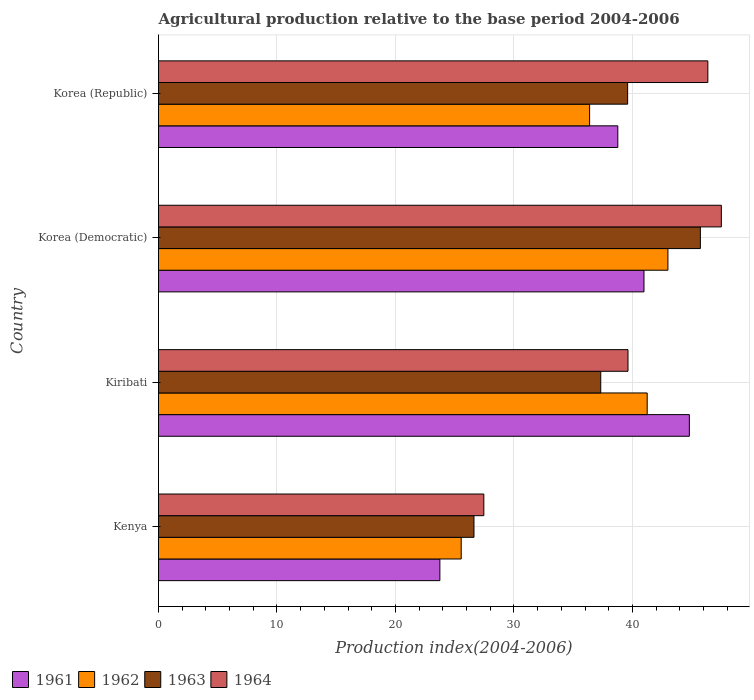How many groups of bars are there?
Your response must be concise. 4. Are the number of bars per tick equal to the number of legend labels?
Make the answer very short. Yes. How many bars are there on the 3rd tick from the top?
Ensure brevity in your answer.  4. What is the label of the 1st group of bars from the top?
Offer a very short reply. Korea (Republic). What is the agricultural production index in 1964 in Korea (Democratic)?
Offer a terse response. 47.51. Across all countries, what is the maximum agricultural production index in 1962?
Your answer should be very brief. 43. Across all countries, what is the minimum agricultural production index in 1962?
Your answer should be very brief. 25.55. In which country was the agricultural production index in 1964 maximum?
Offer a very short reply. Korea (Democratic). In which country was the agricultural production index in 1962 minimum?
Ensure brevity in your answer.  Kenya. What is the total agricultural production index in 1963 in the graph?
Give a very brief answer. 149.3. What is the difference between the agricultural production index in 1964 in Kiribati and that in Korea (Republic)?
Ensure brevity in your answer.  -6.74. What is the difference between the agricultural production index in 1963 in Korea (Republic) and the agricultural production index in 1961 in Korea (Democratic)?
Your response must be concise. -1.38. What is the average agricultural production index in 1964 per country?
Your answer should be compact. 40.24. What is the difference between the agricultural production index in 1961 and agricultural production index in 1964 in Kiribati?
Give a very brief answer. 5.18. What is the ratio of the agricultural production index in 1961 in Kenya to that in Korea (Democratic)?
Make the answer very short. 0.58. Is the agricultural production index in 1962 in Kenya less than that in Korea (Democratic)?
Provide a short and direct response. Yes. Is the difference between the agricultural production index in 1961 in Kiribati and Korea (Republic) greater than the difference between the agricultural production index in 1964 in Kiribati and Korea (Republic)?
Make the answer very short. Yes. What is the difference between the highest and the second highest agricultural production index in 1961?
Offer a very short reply. 3.83. What is the difference between the highest and the lowest agricultural production index in 1961?
Ensure brevity in your answer.  21.06. Is the sum of the agricultural production index in 1964 in Kenya and Kiribati greater than the maximum agricultural production index in 1963 across all countries?
Ensure brevity in your answer.  Yes. Is it the case that in every country, the sum of the agricultural production index in 1964 and agricultural production index in 1963 is greater than the sum of agricultural production index in 1961 and agricultural production index in 1962?
Offer a very short reply. No. What does the 1st bar from the top in Kiribati represents?
Your response must be concise. 1964. How many countries are there in the graph?
Ensure brevity in your answer.  4. What is the difference between two consecutive major ticks on the X-axis?
Your answer should be compact. 10. Are the values on the major ticks of X-axis written in scientific E-notation?
Your answer should be very brief. No. Does the graph contain any zero values?
Offer a very short reply. No. Does the graph contain grids?
Offer a very short reply. Yes. Where does the legend appear in the graph?
Offer a terse response. Bottom left. What is the title of the graph?
Provide a short and direct response. Agricultural production relative to the base period 2004-2006. What is the label or title of the X-axis?
Your answer should be compact. Production index(2004-2006). What is the Production index(2004-2006) in 1961 in Kenya?
Your answer should be compact. 23.75. What is the Production index(2004-2006) of 1962 in Kenya?
Offer a very short reply. 25.55. What is the Production index(2004-2006) in 1963 in Kenya?
Your answer should be very brief. 26.63. What is the Production index(2004-2006) of 1964 in Kenya?
Offer a terse response. 27.46. What is the Production index(2004-2006) in 1961 in Kiribati?
Make the answer very short. 44.81. What is the Production index(2004-2006) of 1962 in Kiribati?
Keep it short and to the point. 41.25. What is the Production index(2004-2006) of 1963 in Kiribati?
Provide a short and direct response. 37.33. What is the Production index(2004-2006) in 1964 in Kiribati?
Ensure brevity in your answer.  39.63. What is the Production index(2004-2006) of 1961 in Korea (Democratic)?
Make the answer very short. 40.98. What is the Production index(2004-2006) in 1963 in Korea (Democratic)?
Offer a very short reply. 45.74. What is the Production index(2004-2006) in 1964 in Korea (Democratic)?
Offer a very short reply. 47.51. What is the Production index(2004-2006) in 1961 in Korea (Republic)?
Offer a very short reply. 38.77. What is the Production index(2004-2006) in 1962 in Korea (Republic)?
Give a very brief answer. 36.39. What is the Production index(2004-2006) of 1963 in Korea (Republic)?
Provide a short and direct response. 39.6. What is the Production index(2004-2006) of 1964 in Korea (Republic)?
Offer a very short reply. 46.37. Across all countries, what is the maximum Production index(2004-2006) in 1961?
Ensure brevity in your answer.  44.81. Across all countries, what is the maximum Production index(2004-2006) of 1962?
Give a very brief answer. 43. Across all countries, what is the maximum Production index(2004-2006) of 1963?
Provide a short and direct response. 45.74. Across all countries, what is the maximum Production index(2004-2006) in 1964?
Your answer should be very brief. 47.51. Across all countries, what is the minimum Production index(2004-2006) in 1961?
Give a very brief answer. 23.75. Across all countries, what is the minimum Production index(2004-2006) in 1962?
Provide a succinct answer. 25.55. Across all countries, what is the minimum Production index(2004-2006) of 1963?
Your answer should be very brief. 26.63. Across all countries, what is the minimum Production index(2004-2006) of 1964?
Offer a very short reply. 27.46. What is the total Production index(2004-2006) of 1961 in the graph?
Offer a very short reply. 148.31. What is the total Production index(2004-2006) in 1962 in the graph?
Offer a terse response. 146.19. What is the total Production index(2004-2006) of 1963 in the graph?
Keep it short and to the point. 149.3. What is the total Production index(2004-2006) of 1964 in the graph?
Give a very brief answer. 160.97. What is the difference between the Production index(2004-2006) in 1961 in Kenya and that in Kiribati?
Make the answer very short. -21.06. What is the difference between the Production index(2004-2006) in 1962 in Kenya and that in Kiribati?
Offer a very short reply. -15.7. What is the difference between the Production index(2004-2006) of 1963 in Kenya and that in Kiribati?
Provide a short and direct response. -10.7. What is the difference between the Production index(2004-2006) in 1964 in Kenya and that in Kiribati?
Offer a very short reply. -12.17. What is the difference between the Production index(2004-2006) of 1961 in Kenya and that in Korea (Democratic)?
Offer a terse response. -17.23. What is the difference between the Production index(2004-2006) of 1962 in Kenya and that in Korea (Democratic)?
Make the answer very short. -17.45. What is the difference between the Production index(2004-2006) in 1963 in Kenya and that in Korea (Democratic)?
Give a very brief answer. -19.11. What is the difference between the Production index(2004-2006) in 1964 in Kenya and that in Korea (Democratic)?
Your answer should be compact. -20.05. What is the difference between the Production index(2004-2006) of 1961 in Kenya and that in Korea (Republic)?
Provide a short and direct response. -15.02. What is the difference between the Production index(2004-2006) of 1962 in Kenya and that in Korea (Republic)?
Your answer should be very brief. -10.84. What is the difference between the Production index(2004-2006) in 1963 in Kenya and that in Korea (Republic)?
Offer a very short reply. -12.97. What is the difference between the Production index(2004-2006) in 1964 in Kenya and that in Korea (Republic)?
Your answer should be very brief. -18.91. What is the difference between the Production index(2004-2006) of 1961 in Kiribati and that in Korea (Democratic)?
Your answer should be compact. 3.83. What is the difference between the Production index(2004-2006) in 1962 in Kiribati and that in Korea (Democratic)?
Offer a terse response. -1.75. What is the difference between the Production index(2004-2006) of 1963 in Kiribati and that in Korea (Democratic)?
Make the answer very short. -8.41. What is the difference between the Production index(2004-2006) of 1964 in Kiribati and that in Korea (Democratic)?
Your response must be concise. -7.88. What is the difference between the Production index(2004-2006) of 1961 in Kiribati and that in Korea (Republic)?
Keep it short and to the point. 6.04. What is the difference between the Production index(2004-2006) of 1962 in Kiribati and that in Korea (Republic)?
Keep it short and to the point. 4.86. What is the difference between the Production index(2004-2006) in 1963 in Kiribati and that in Korea (Republic)?
Make the answer very short. -2.27. What is the difference between the Production index(2004-2006) in 1964 in Kiribati and that in Korea (Republic)?
Ensure brevity in your answer.  -6.74. What is the difference between the Production index(2004-2006) of 1961 in Korea (Democratic) and that in Korea (Republic)?
Your answer should be very brief. 2.21. What is the difference between the Production index(2004-2006) in 1962 in Korea (Democratic) and that in Korea (Republic)?
Provide a succinct answer. 6.61. What is the difference between the Production index(2004-2006) in 1963 in Korea (Democratic) and that in Korea (Republic)?
Provide a short and direct response. 6.14. What is the difference between the Production index(2004-2006) in 1964 in Korea (Democratic) and that in Korea (Republic)?
Your answer should be compact. 1.14. What is the difference between the Production index(2004-2006) of 1961 in Kenya and the Production index(2004-2006) of 1962 in Kiribati?
Give a very brief answer. -17.5. What is the difference between the Production index(2004-2006) in 1961 in Kenya and the Production index(2004-2006) in 1963 in Kiribati?
Make the answer very short. -13.58. What is the difference between the Production index(2004-2006) in 1961 in Kenya and the Production index(2004-2006) in 1964 in Kiribati?
Offer a very short reply. -15.88. What is the difference between the Production index(2004-2006) of 1962 in Kenya and the Production index(2004-2006) of 1963 in Kiribati?
Make the answer very short. -11.78. What is the difference between the Production index(2004-2006) of 1962 in Kenya and the Production index(2004-2006) of 1964 in Kiribati?
Your answer should be very brief. -14.08. What is the difference between the Production index(2004-2006) in 1961 in Kenya and the Production index(2004-2006) in 1962 in Korea (Democratic)?
Ensure brevity in your answer.  -19.25. What is the difference between the Production index(2004-2006) of 1961 in Kenya and the Production index(2004-2006) of 1963 in Korea (Democratic)?
Offer a terse response. -21.99. What is the difference between the Production index(2004-2006) of 1961 in Kenya and the Production index(2004-2006) of 1964 in Korea (Democratic)?
Provide a succinct answer. -23.76. What is the difference between the Production index(2004-2006) in 1962 in Kenya and the Production index(2004-2006) in 1963 in Korea (Democratic)?
Keep it short and to the point. -20.19. What is the difference between the Production index(2004-2006) in 1962 in Kenya and the Production index(2004-2006) in 1964 in Korea (Democratic)?
Provide a succinct answer. -21.96. What is the difference between the Production index(2004-2006) in 1963 in Kenya and the Production index(2004-2006) in 1964 in Korea (Democratic)?
Your response must be concise. -20.88. What is the difference between the Production index(2004-2006) of 1961 in Kenya and the Production index(2004-2006) of 1962 in Korea (Republic)?
Keep it short and to the point. -12.64. What is the difference between the Production index(2004-2006) in 1961 in Kenya and the Production index(2004-2006) in 1963 in Korea (Republic)?
Your response must be concise. -15.85. What is the difference between the Production index(2004-2006) in 1961 in Kenya and the Production index(2004-2006) in 1964 in Korea (Republic)?
Make the answer very short. -22.62. What is the difference between the Production index(2004-2006) in 1962 in Kenya and the Production index(2004-2006) in 1963 in Korea (Republic)?
Provide a short and direct response. -14.05. What is the difference between the Production index(2004-2006) in 1962 in Kenya and the Production index(2004-2006) in 1964 in Korea (Republic)?
Provide a succinct answer. -20.82. What is the difference between the Production index(2004-2006) of 1963 in Kenya and the Production index(2004-2006) of 1964 in Korea (Republic)?
Offer a very short reply. -19.74. What is the difference between the Production index(2004-2006) in 1961 in Kiribati and the Production index(2004-2006) in 1962 in Korea (Democratic)?
Provide a short and direct response. 1.81. What is the difference between the Production index(2004-2006) in 1961 in Kiribati and the Production index(2004-2006) in 1963 in Korea (Democratic)?
Provide a short and direct response. -0.93. What is the difference between the Production index(2004-2006) of 1961 in Kiribati and the Production index(2004-2006) of 1964 in Korea (Democratic)?
Your answer should be very brief. -2.7. What is the difference between the Production index(2004-2006) in 1962 in Kiribati and the Production index(2004-2006) in 1963 in Korea (Democratic)?
Offer a very short reply. -4.49. What is the difference between the Production index(2004-2006) of 1962 in Kiribati and the Production index(2004-2006) of 1964 in Korea (Democratic)?
Provide a short and direct response. -6.26. What is the difference between the Production index(2004-2006) in 1963 in Kiribati and the Production index(2004-2006) in 1964 in Korea (Democratic)?
Your response must be concise. -10.18. What is the difference between the Production index(2004-2006) of 1961 in Kiribati and the Production index(2004-2006) of 1962 in Korea (Republic)?
Your answer should be very brief. 8.42. What is the difference between the Production index(2004-2006) in 1961 in Kiribati and the Production index(2004-2006) in 1963 in Korea (Republic)?
Provide a short and direct response. 5.21. What is the difference between the Production index(2004-2006) in 1961 in Kiribati and the Production index(2004-2006) in 1964 in Korea (Republic)?
Keep it short and to the point. -1.56. What is the difference between the Production index(2004-2006) in 1962 in Kiribati and the Production index(2004-2006) in 1963 in Korea (Republic)?
Offer a terse response. 1.65. What is the difference between the Production index(2004-2006) of 1962 in Kiribati and the Production index(2004-2006) of 1964 in Korea (Republic)?
Your answer should be compact. -5.12. What is the difference between the Production index(2004-2006) in 1963 in Kiribati and the Production index(2004-2006) in 1964 in Korea (Republic)?
Give a very brief answer. -9.04. What is the difference between the Production index(2004-2006) of 1961 in Korea (Democratic) and the Production index(2004-2006) of 1962 in Korea (Republic)?
Offer a terse response. 4.59. What is the difference between the Production index(2004-2006) in 1961 in Korea (Democratic) and the Production index(2004-2006) in 1963 in Korea (Republic)?
Offer a terse response. 1.38. What is the difference between the Production index(2004-2006) of 1961 in Korea (Democratic) and the Production index(2004-2006) of 1964 in Korea (Republic)?
Provide a succinct answer. -5.39. What is the difference between the Production index(2004-2006) in 1962 in Korea (Democratic) and the Production index(2004-2006) in 1963 in Korea (Republic)?
Provide a short and direct response. 3.4. What is the difference between the Production index(2004-2006) in 1962 in Korea (Democratic) and the Production index(2004-2006) in 1964 in Korea (Republic)?
Your answer should be very brief. -3.37. What is the difference between the Production index(2004-2006) in 1963 in Korea (Democratic) and the Production index(2004-2006) in 1964 in Korea (Republic)?
Keep it short and to the point. -0.63. What is the average Production index(2004-2006) of 1961 per country?
Ensure brevity in your answer.  37.08. What is the average Production index(2004-2006) of 1962 per country?
Offer a terse response. 36.55. What is the average Production index(2004-2006) in 1963 per country?
Ensure brevity in your answer.  37.33. What is the average Production index(2004-2006) in 1964 per country?
Keep it short and to the point. 40.24. What is the difference between the Production index(2004-2006) of 1961 and Production index(2004-2006) of 1963 in Kenya?
Keep it short and to the point. -2.88. What is the difference between the Production index(2004-2006) of 1961 and Production index(2004-2006) of 1964 in Kenya?
Offer a very short reply. -3.71. What is the difference between the Production index(2004-2006) of 1962 and Production index(2004-2006) of 1963 in Kenya?
Your response must be concise. -1.08. What is the difference between the Production index(2004-2006) of 1962 and Production index(2004-2006) of 1964 in Kenya?
Make the answer very short. -1.91. What is the difference between the Production index(2004-2006) in 1963 and Production index(2004-2006) in 1964 in Kenya?
Make the answer very short. -0.83. What is the difference between the Production index(2004-2006) of 1961 and Production index(2004-2006) of 1962 in Kiribati?
Your answer should be very brief. 3.56. What is the difference between the Production index(2004-2006) in 1961 and Production index(2004-2006) in 1963 in Kiribati?
Offer a very short reply. 7.48. What is the difference between the Production index(2004-2006) of 1961 and Production index(2004-2006) of 1964 in Kiribati?
Make the answer very short. 5.18. What is the difference between the Production index(2004-2006) in 1962 and Production index(2004-2006) in 1963 in Kiribati?
Provide a short and direct response. 3.92. What is the difference between the Production index(2004-2006) in 1962 and Production index(2004-2006) in 1964 in Kiribati?
Your response must be concise. 1.62. What is the difference between the Production index(2004-2006) in 1961 and Production index(2004-2006) in 1962 in Korea (Democratic)?
Your response must be concise. -2.02. What is the difference between the Production index(2004-2006) in 1961 and Production index(2004-2006) in 1963 in Korea (Democratic)?
Your answer should be compact. -4.76. What is the difference between the Production index(2004-2006) in 1961 and Production index(2004-2006) in 1964 in Korea (Democratic)?
Provide a succinct answer. -6.53. What is the difference between the Production index(2004-2006) of 1962 and Production index(2004-2006) of 1963 in Korea (Democratic)?
Your response must be concise. -2.74. What is the difference between the Production index(2004-2006) in 1962 and Production index(2004-2006) in 1964 in Korea (Democratic)?
Keep it short and to the point. -4.51. What is the difference between the Production index(2004-2006) in 1963 and Production index(2004-2006) in 1964 in Korea (Democratic)?
Offer a terse response. -1.77. What is the difference between the Production index(2004-2006) of 1961 and Production index(2004-2006) of 1962 in Korea (Republic)?
Your response must be concise. 2.38. What is the difference between the Production index(2004-2006) in 1961 and Production index(2004-2006) in 1963 in Korea (Republic)?
Your answer should be very brief. -0.83. What is the difference between the Production index(2004-2006) in 1962 and Production index(2004-2006) in 1963 in Korea (Republic)?
Your response must be concise. -3.21. What is the difference between the Production index(2004-2006) in 1962 and Production index(2004-2006) in 1964 in Korea (Republic)?
Give a very brief answer. -9.98. What is the difference between the Production index(2004-2006) in 1963 and Production index(2004-2006) in 1964 in Korea (Republic)?
Offer a very short reply. -6.77. What is the ratio of the Production index(2004-2006) of 1961 in Kenya to that in Kiribati?
Provide a short and direct response. 0.53. What is the ratio of the Production index(2004-2006) in 1962 in Kenya to that in Kiribati?
Keep it short and to the point. 0.62. What is the ratio of the Production index(2004-2006) in 1963 in Kenya to that in Kiribati?
Give a very brief answer. 0.71. What is the ratio of the Production index(2004-2006) of 1964 in Kenya to that in Kiribati?
Provide a succinct answer. 0.69. What is the ratio of the Production index(2004-2006) in 1961 in Kenya to that in Korea (Democratic)?
Your response must be concise. 0.58. What is the ratio of the Production index(2004-2006) in 1962 in Kenya to that in Korea (Democratic)?
Give a very brief answer. 0.59. What is the ratio of the Production index(2004-2006) of 1963 in Kenya to that in Korea (Democratic)?
Make the answer very short. 0.58. What is the ratio of the Production index(2004-2006) in 1964 in Kenya to that in Korea (Democratic)?
Keep it short and to the point. 0.58. What is the ratio of the Production index(2004-2006) in 1961 in Kenya to that in Korea (Republic)?
Provide a succinct answer. 0.61. What is the ratio of the Production index(2004-2006) of 1962 in Kenya to that in Korea (Republic)?
Make the answer very short. 0.7. What is the ratio of the Production index(2004-2006) of 1963 in Kenya to that in Korea (Republic)?
Your answer should be very brief. 0.67. What is the ratio of the Production index(2004-2006) in 1964 in Kenya to that in Korea (Republic)?
Your response must be concise. 0.59. What is the ratio of the Production index(2004-2006) of 1961 in Kiribati to that in Korea (Democratic)?
Your answer should be very brief. 1.09. What is the ratio of the Production index(2004-2006) of 1962 in Kiribati to that in Korea (Democratic)?
Make the answer very short. 0.96. What is the ratio of the Production index(2004-2006) in 1963 in Kiribati to that in Korea (Democratic)?
Your response must be concise. 0.82. What is the ratio of the Production index(2004-2006) of 1964 in Kiribati to that in Korea (Democratic)?
Offer a terse response. 0.83. What is the ratio of the Production index(2004-2006) in 1961 in Kiribati to that in Korea (Republic)?
Offer a very short reply. 1.16. What is the ratio of the Production index(2004-2006) in 1962 in Kiribati to that in Korea (Republic)?
Make the answer very short. 1.13. What is the ratio of the Production index(2004-2006) of 1963 in Kiribati to that in Korea (Republic)?
Keep it short and to the point. 0.94. What is the ratio of the Production index(2004-2006) of 1964 in Kiribati to that in Korea (Republic)?
Provide a succinct answer. 0.85. What is the ratio of the Production index(2004-2006) in 1961 in Korea (Democratic) to that in Korea (Republic)?
Provide a succinct answer. 1.06. What is the ratio of the Production index(2004-2006) of 1962 in Korea (Democratic) to that in Korea (Republic)?
Provide a succinct answer. 1.18. What is the ratio of the Production index(2004-2006) in 1963 in Korea (Democratic) to that in Korea (Republic)?
Your answer should be very brief. 1.16. What is the ratio of the Production index(2004-2006) of 1964 in Korea (Democratic) to that in Korea (Republic)?
Your answer should be compact. 1.02. What is the difference between the highest and the second highest Production index(2004-2006) in 1961?
Your answer should be compact. 3.83. What is the difference between the highest and the second highest Production index(2004-2006) in 1962?
Provide a succinct answer. 1.75. What is the difference between the highest and the second highest Production index(2004-2006) in 1963?
Provide a short and direct response. 6.14. What is the difference between the highest and the second highest Production index(2004-2006) of 1964?
Keep it short and to the point. 1.14. What is the difference between the highest and the lowest Production index(2004-2006) in 1961?
Provide a short and direct response. 21.06. What is the difference between the highest and the lowest Production index(2004-2006) of 1962?
Give a very brief answer. 17.45. What is the difference between the highest and the lowest Production index(2004-2006) in 1963?
Provide a succinct answer. 19.11. What is the difference between the highest and the lowest Production index(2004-2006) of 1964?
Your answer should be compact. 20.05. 